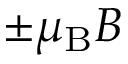Convert formula to latex. <formula><loc_0><loc_0><loc_500><loc_500>\pm \mu _ { B } B</formula> 